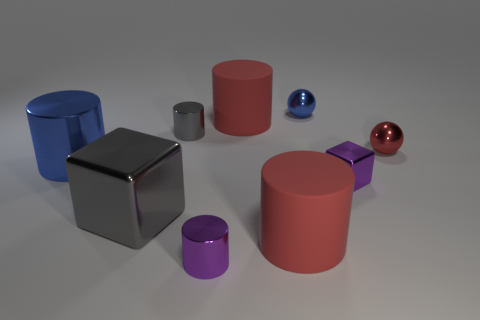Subtract all large red matte cylinders. How many cylinders are left? 3 Add 1 large green matte cylinders. How many objects exist? 10 Subtract 4 cylinders. How many cylinders are left? 1 Subtract all purple cubes. How many red cylinders are left? 2 Subtract all red spheres. How many spheres are left? 1 Add 4 metallic cylinders. How many metallic cylinders are left? 7 Add 8 red metallic objects. How many red metallic objects exist? 9 Subtract 0 gray balls. How many objects are left? 9 Subtract all balls. How many objects are left? 7 Subtract all gray cylinders. Subtract all blue blocks. How many cylinders are left? 4 